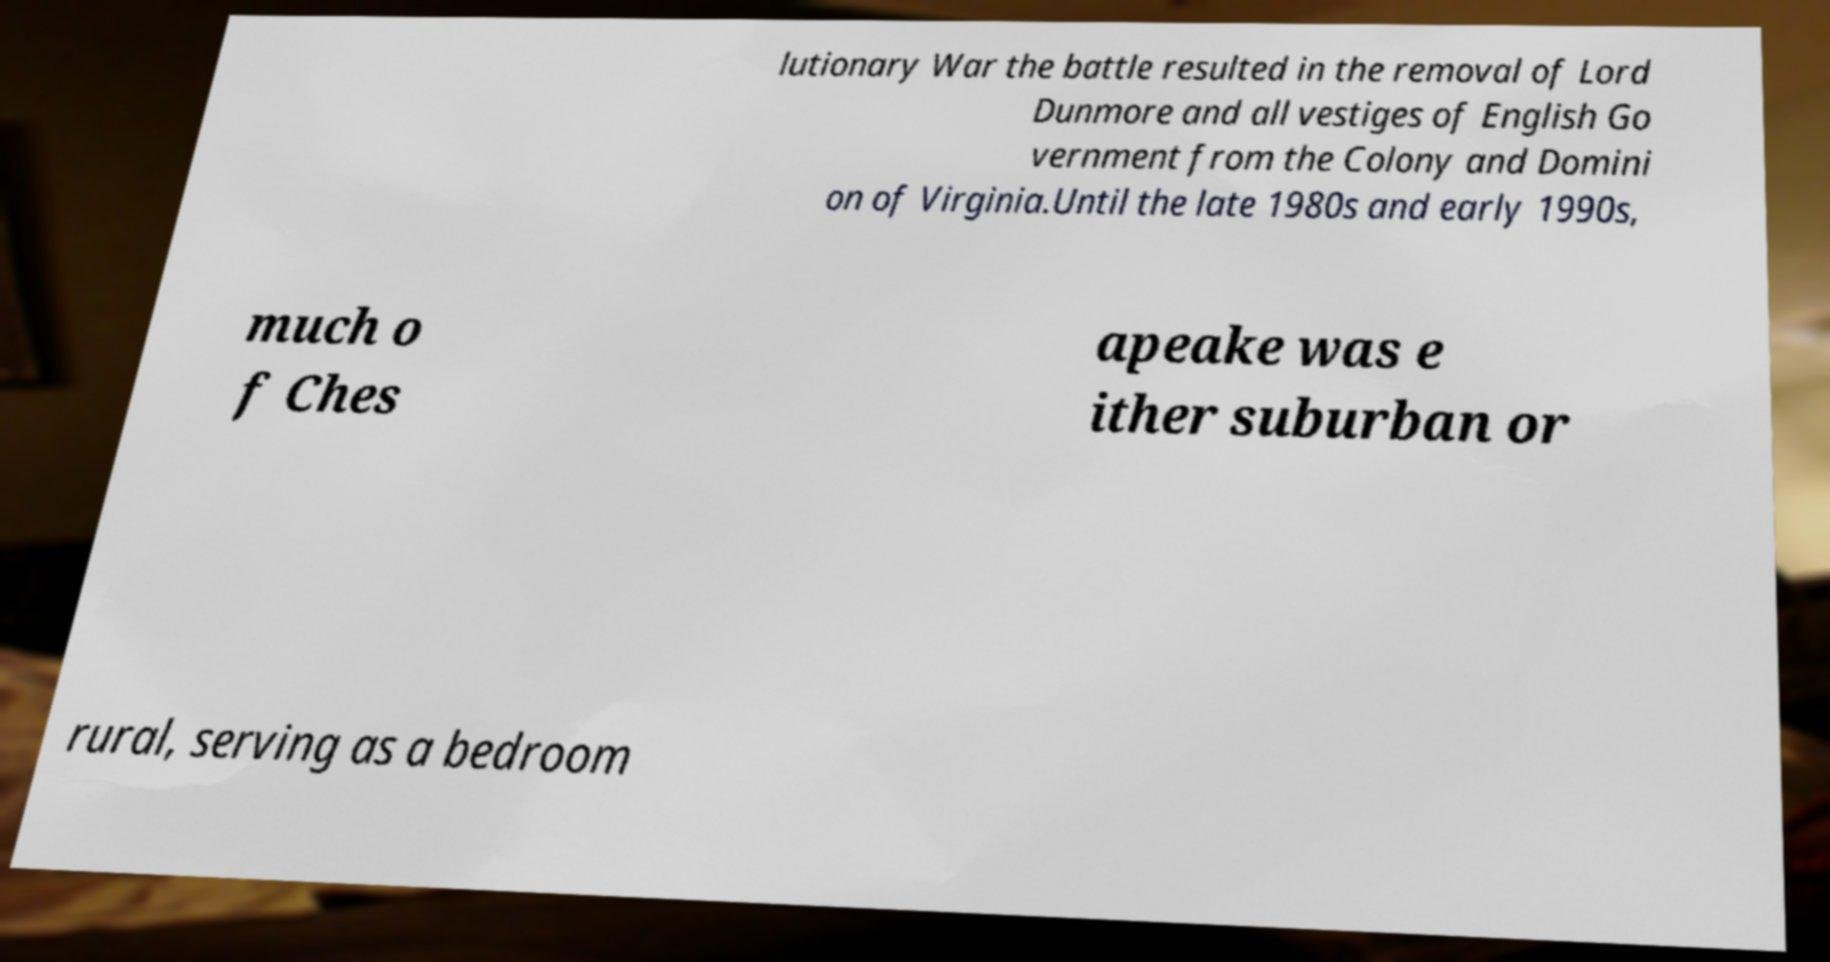Could you assist in decoding the text presented in this image and type it out clearly? lutionary War the battle resulted in the removal of Lord Dunmore and all vestiges of English Go vernment from the Colony and Domini on of Virginia.Until the late 1980s and early 1990s, much o f Ches apeake was e ither suburban or rural, serving as a bedroom 